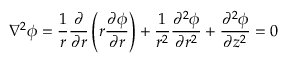<formula> <loc_0><loc_0><loc_500><loc_500>\nabla ^ { 2 } \phi = \frac { 1 } { r } \frac { \partial } { \partial r } \left ( r \frac { \partial \phi } { \partial r } \right ) + \frac { 1 } { r ^ { 2 } } \frac { \partial ^ { 2 } \phi } { \partial r ^ { 2 } } + \frac { \partial ^ { 2 } \phi } { \partial z ^ { 2 } } = 0</formula> 